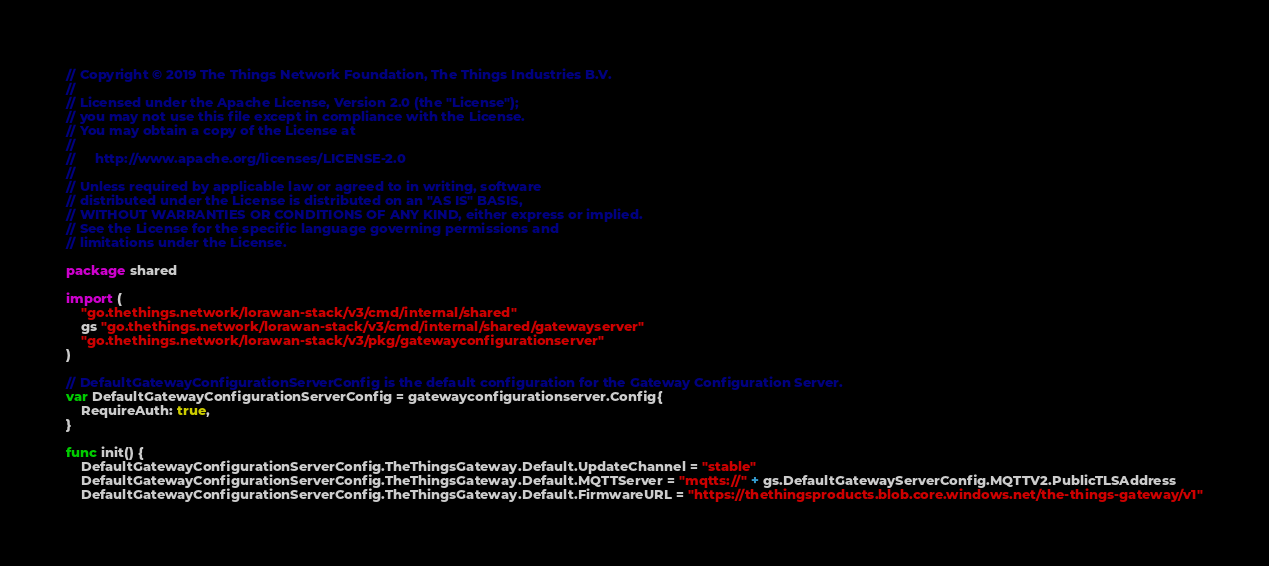Convert code to text. <code><loc_0><loc_0><loc_500><loc_500><_Go_>// Copyright © 2019 The Things Network Foundation, The Things Industries B.V.
//
// Licensed under the Apache License, Version 2.0 (the "License");
// you may not use this file except in compliance with the License.
// You may obtain a copy of the License at
//
//     http://www.apache.org/licenses/LICENSE-2.0
//
// Unless required by applicable law or agreed to in writing, software
// distributed under the License is distributed on an "AS IS" BASIS,
// WITHOUT WARRANTIES OR CONDITIONS OF ANY KIND, either express or implied.
// See the License for the specific language governing permissions and
// limitations under the License.

package shared

import (
	"go.thethings.network/lorawan-stack/v3/cmd/internal/shared"
	gs "go.thethings.network/lorawan-stack/v3/cmd/internal/shared/gatewayserver"
	"go.thethings.network/lorawan-stack/v3/pkg/gatewayconfigurationserver"
)

// DefaultGatewayConfigurationServerConfig is the default configuration for the Gateway Configuration Server.
var DefaultGatewayConfigurationServerConfig = gatewayconfigurationserver.Config{
	RequireAuth: true,
}

func init() {
	DefaultGatewayConfigurationServerConfig.TheThingsGateway.Default.UpdateChannel = "stable"
	DefaultGatewayConfigurationServerConfig.TheThingsGateway.Default.MQTTServer = "mqtts://" + gs.DefaultGatewayServerConfig.MQTTV2.PublicTLSAddress
	DefaultGatewayConfigurationServerConfig.TheThingsGateway.Default.FirmwareURL = "https://thethingsproducts.blob.core.windows.net/the-things-gateway/v1"</code> 